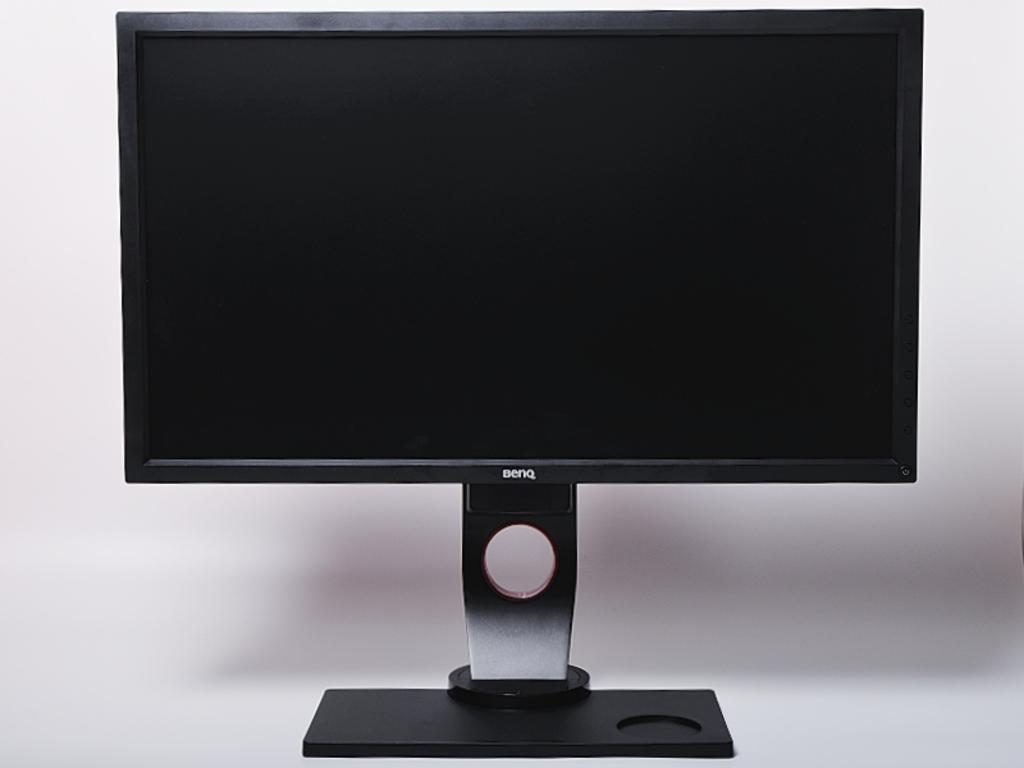<image>
Relay a brief, clear account of the picture shown. A Benq computer monitor shows a blank black screen. 